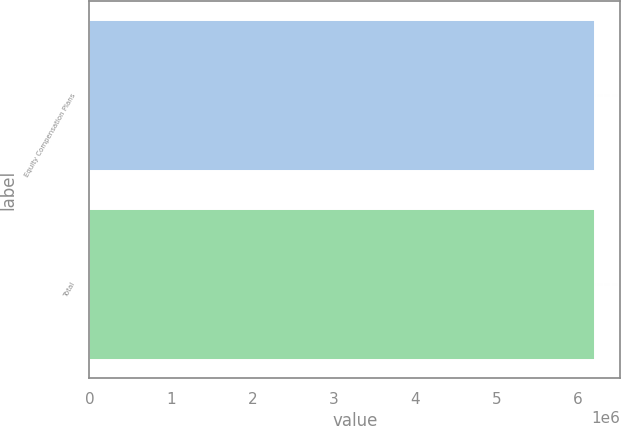Convert chart to OTSL. <chart><loc_0><loc_0><loc_500><loc_500><bar_chart><fcel>Equity Compensation Plans<fcel>Total<nl><fcel>6.20579e+06<fcel>6.20579e+06<nl></chart> 